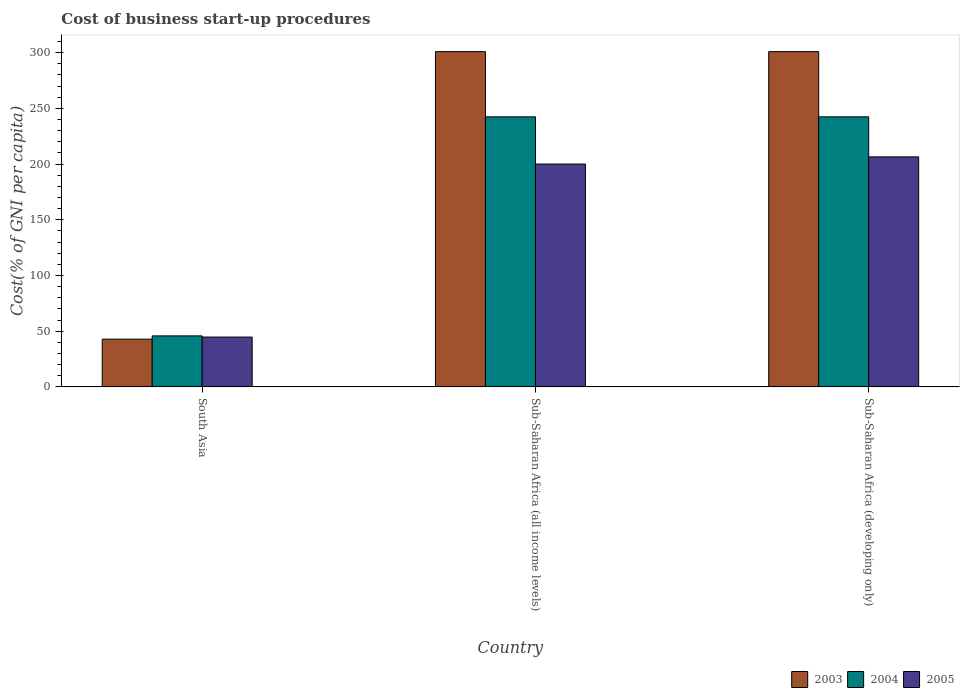How many groups of bars are there?
Offer a terse response. 3. Are the number of bars per tick equal to the number of legend labels?
Your response must be concise. Yes. How many bars are there on the 1st tick from the left?
Keep it short and to the point. 3. How many bars are there on the 3rd tick from the right?
Provide a short and direct response. 3. What is the cost of business start-up procedures in 2003 in South Asia?
Make the answer very short. 42.83. Across all countries, what is the maximum cost of business start-up procedures in 2004?
Your answer should be compact. 242.35. Across all countries, what is the minimum cost of business start-up procedures in 2005?
Your response must be concise. 44.7. In which country was the cost of business start-up procedures in 2005 maximum?
Your answer should be compact. Sub-Saharan Africa (developing only). What is the total cost of business start-up procedures in 2004 in the graph?
Provide a succinct answer. 530.45. What is the difference between the cost of business start-up procedures in 2004 in South Asia and that in Sub-Saharan Africa (all income levels)?
Keep it short and to the point. -196.59. What is the difference between the cost of business start-up procedures in 2005 in Sub-Saharan Africa (developing only) and the cost of business start-up procedures in 2004 in South Asia?
Offer a terse response. 160.66. What is the average cost of business start-up procedures in 2005 per country?
Your answer should be compact. 150.37. What is the difference between the cost of business start-up procedures of/in 2005 and cost of business start-up procedures of/in 2004 in Sub-Saharan Africa (all income levels)?
Provide a short and direct response. -42.35. Is the difference between the cost of business start-up procedures in 2005 in South Asia and Sub-Saharan Africa (all income levels) greater than the difference between the cost of business start-up procedures in 2004 in South Asia and Sub-Saharan Africa (all income levels)?
Your response must be concise. Yes. What is the difference between the highest and the second highest cost of business start-up procedures in 2004?
Your answer should be very brief. 196.59. What is the difference between the highest and the lowest cost of business start-up procedures in 2004?
Offer a very short reply. 196.59. Is the sum of the cost of business start-up procedures in 2003 in South Asia and Sub-Saharan Africa (developing only) greater than the maximum cost of business start-up procedures in 2004 across all countries?
Your answer should be very brief. Yes. Is it the case that in every country, the sum of the cost of business start-up procedures in 2005 and cost of business start-up procedures in 2003 is greater than the cost of business start-up procedures in 2004?
Make the answer very short. Yes. How many bars are there?
Offer a terse response. 9. Are all the bars in the graph horizontal?
Offer a very short reply. No. Are the values on the major ticks of Y-axis written in scientific E-notation?
Provide a short and direct response. No. Does the graph contain any zero values?
Keep it short and to the point. No. Does the graph contain grids?
Your answer should be compact. No. Where does the legend appear in the graph?
Offer a terse response. Bottom right. What is the title of the graph?
Your answer should be very brief. Cost of business start-up procedures. Does "1974" appear as one of the legend labels in the graph?
Provide a short and direct response. No. What is the label or title of the Y-axis?
Keep it short and to the point. Cost(% of GNI per capita). What is the Cost(% of GNI per capita) in 2003 in South Asia?
Make the answer very short. 42.83. What is the Cost(% of GNI per capita) of 2004 in South Asia?
Make the answer very short. 45.76. What is the Cost(% of GNI per capita) of 2005 in South Asia?
Your response must be concise. 44.7. What is the Cost(% of GNI per capita) of 2003 in Sub-Saharan Africa (all income levels)?
Provide a short and direct response. 300.87. What is the Cost(% of GNI per capita) of 2004 in Sub-Saharan Africa (all income levels)?
Offer a terse response. 242.35. What is the Cost(% of GNI per capita) in 2005 in Sub-Saharan Africa (all income levels)?
Provide a short and direct response. 200. What is the Cost(% of GNI per capita) in 2003 in Sub-Saharan Africa (developing only)?
Ensure brevity in your answer.  300.87. What is the Cost(% of GNI per capita) of 2004 in Sub-Saharan Africa (developing only)?
Your answer should be compact. 242.35. What is the Cost(% of GNI per capita) of 2005 in Sub-Saharan Africa (developing only)?
Provide a short and direct response. 206.42. Across all countries, what is the maximum Cost(% of GNI per capita) in 2003?
Your answer should be very brief. 300.87. Across all countries, what is the maximum Cost(% of GNI per capita) of 2004?
Provide a short and direct response. 242.35. Across all countries, what is the maximum Cost(% of GNI per capita) in 2005?
Ensure brevity in your answer.  206.42. Across all countries, what is the minimum Cost(% of GNI per capita) of 2003?
Ensure brevity in your answer.  42.83. Across all countries, what is the minimum Cost(% of GNI per capita) of 2004?
Provide a succinct answer. 45.76. Across all countries, what is the minimum Cost(% of GNI per capita) of 2005?
Your response must be concise. 44.7. What is the total Cost(% of GNI per capita) of 2003 in the graph?
Your answer should be very brief. 644.56. What is the total Cost(% of GNI per capita) of 2004 in the graph?
Offer a very short reply. 530.45. What is the total Cost(% of GNI per capita) of 2005 in the graph?
Provide a short and direct response. 451.12. What is the difference between the Cost(% of GNI per capita) of 2003 in South Asia and that in Sub-Saharan Africa (all income levels)?
Ensure brevity in your answer.  -258.04. What is the difference between the Cost(% of GNI per capita) of 2004 in South Asia and that in Sub-Saharan Africa (all income levels)?
Provide a succinct answer. -196.59. What is the difference between the Cost(% of GNI per capita) in 2005 in South Asia and that in Sub-Saharan Africa (all income levels)?
Give a very brief answer. -155.3. What is the difference between the Cost(% of GNI per capita) in 2003 in South Asia and that in Sub-Saharan Africa (developing only)?
Offer a very short reply. -258.04. What is the difference between the Cost(% of GNI per capita) of 2004 in South Asia and that in Sub-Saharan Africa (developing only)?
Your answer should be compact. -196.59. What is the difference between the Cost(% of GNI per capita) of 2005 in South Asia and that in Sub-Saharan Africa (developing only)?
Offer a terse response. -161.72. What is the difference between the Cost(% of GNI per capita) of 2005 in Sub-Saharan Africa (all income levels) and that in Sub-Saharan Africa (developing only)?
Offer a terse response. -6.42. What is the difference between the Cost(% of GNI per capita) in 2003 in South Asia and the Cost(% of GNI per capita) in 2004 in Sub-Saharan Africa (all income levels)?
Your response must be concise. -199.52. What is the difference between the Cost(% of GNI per capita) of 2003 in South Asia and the Cost(% of GNI per capita) of 2005 in Sub-Saharan Africa (all income levels)?
Provide a short and direct response. -157.17. What is the difference between the Cost(% of GNI per capita) in 2004 in South Asia and the Cost(% of GNI per capita) in 2005 in Sub-Saharan Africa (all income levels)?
Make the answer very short. -154.24. What is the difference between the Cost(% of GNI per capita) of 2003 in South Asia and the Cost(% of GNI per capita) of 2004 in Sub-Saharan Africa (developing only)?
Offer a terse response. -199.52. What is the difference between the Cost(% of GNI per capita) of 2003 in South Asia and the Cost(% of GNI per capita) of 2005 in Sub-Saharan Africa (developing only)?
Offer a terse response. -163.59. What is the difference between the Cost(% of GNI per capita) in 2004 in South Asia and the Cost(% of GNI per capita) in 2005 in Sub-Saharan Africa (developing only)?
Your answer should be very brief. -160.66. What is the difference between the Cost(% of GNI per capita) in 2003 in Sub-Saharan Africa (all income levels) and the Cost(% of GNI per capita) in 2004 in Sub-Saharan Africa (developing only)?
Offer a very short reply. 58.52. What is the difference between the Cost(% of GNI per capita) in 2003 in Sub-Saharan Africa (all income levels) and the Cost(% of GNI per capita) in 2005 in Sub-Saharan Africa (developing only)?
Offer a very short reply. 94.45. What is the difference between the Cost(% of GNI per capita) of 2004 in Sub-Saharan Africa (all income levels) and the Cost(% of GNI per capita) of 2005 in Sub-Saharan Africa (developing only)?
Make the answer very short. 35.93. What is the average Cost(% of GNI per capita) in 2003 per country?
Your answer should be compact. 214.85. What is the average Cost(% of GNI per capita) of 2004 per country?
Give a very brief answer. 176.82. What is the average Cost(% of GNI per capita) of 2005 per country?
Your answer should be compact. 150.37. What is the difference between the Cost(% of GNI per capita) in 2003 and Cost(% of GNI per capita) in 2004 in South Asia?
Your answer should be very brief. -2.94. What is the difference between the Cost(% of GNI per capita) of 2003 and Cost(% of GNI per capita) of 2005 in South Asia?
Offer a very short reply. -1.88. What is the difference between the Cost(% of GNI per capita) in 2004 and Cost(% of GNI per capita) in 2005 in South Asia?
Make the answer very short. 1.06. What is the difference between the Cost(% of GNI per capita) of 2003 and Cost(% of GNI per capita) of 2004 in Sub-Saharan Africa (all income levels)?
Your response must be concise. 58.52. What is the difference between the Cost(% of GNI per capita) of 2003 and Cost(% of GNI per capita) of 2005 in Sub-Saharan Africa (all income levels)?
Your response must be concise. 100.87. What is the difference between the Cost(% of GNI per capita) in 2004 and Cost(% of GNI per capita) in 2005 in Sub-Saharan Africa (all income levels)?
Your response must be concise. 42.35. What is the difference between the Cost(% of GNI per capita) in 2003 and Cost(% of GNI per capita) in 2004 in Sub-Saharan Africa (developing only)?
Your answer should be compact. 58.52. What is the difference between the Cost(% of GNI per capita) of 2003 and Cost(% of GNI per capita) of 2005 in Sub-Saharan Africa (developing only)?
Provide a succinct answer. 94.45. What is the difference between the Cost(% of GNI per capita) in 2004 and Cost(% of GNI per capita) in 2005 in Sub-Saharan Africa (developing only)?
Ensure brevity in your answer.  35.93. What is the ratio of the Cost(% of GNI per capita) in 2003 in South Asia to that in Sub-Saharan Africa (all income levels)?
Make the answer very short. 0.14. What is the ratio of the Cost(% of GNI per capita) in 2004 in South Asia to that in Sub-Saharan Africa (all income levels)?
Your response must be concise. 0.19. What is the ratio of the Cost(% of GNI per capita) of 2005 in South Asia to that in Sub-Saharan Africa (all income levels)?
Provide a succinct answer. 0.22. What is the ratio of the Cost(% of GNI per capita) in 2003 in South Asia to that in Sub-Saharan Africa (developing only)?
Keep it short and to the point. 0.14. What is the ratio of the Cost(% of GNI per capita) of 2004 in South Asia to that in Sub-Saharan Africa (developing only)?
Provide a short and direct response. 0.19. What is the ratio of the Cost(% of GNI per capita) in 2005 in South Asia to that in Sub-Saharan Africa (developing only)?
Offer a very short reply. 0.22. What is the ratio of the Cost(% of GNI per capita) of 2005 in Sub-Saharan Africa (all income levels) to that in Sub-Saharan Africa (developing only)?
Offer a very short reply. 0.97. What is the difference between the highest and the second highest Cost(% of GNI per capita) of 2003?
Provide a short and direct response. 0. What is the difference between the highest and the second highest Cost(% of GNI per capita) of 2005?
Your answer should be very brief. 6.42. What is the difference between the highest and the lowest Cost(% of GNI per capita) in 2003?
Offer a very short reply. 258.04. What is the difference between the highest and the lowest Cost(% of GNI per capita) of 2004?
Offer a terse response. 196.59. What is the difference between the highest and the lowest Cost(% of GNI per capita) of 2005?
Keep it short and to the point. 161.72. 